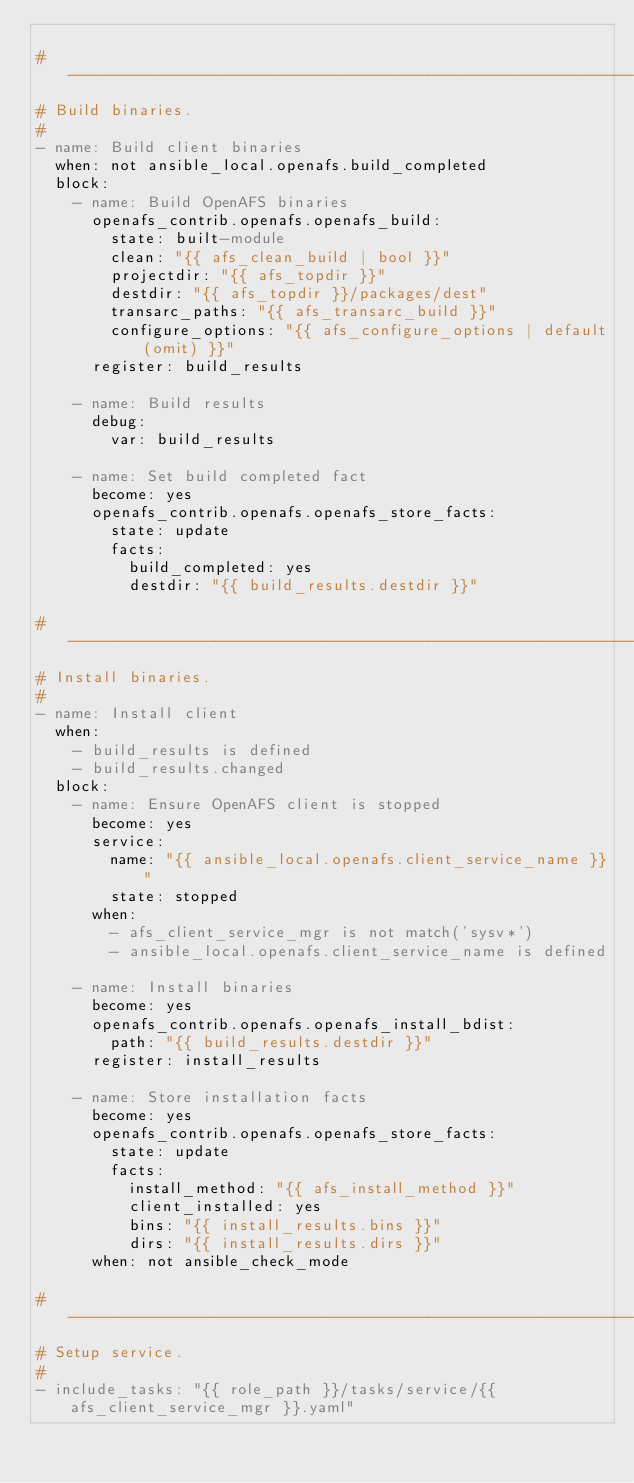Convert code to text. <code><loc_0><loc_0><loc_500><loc_500><_YAML_>
#----------------------------------------------------------------------------
# Build binaries.
#
- name: Build client binaries
  when: not ansible_local.openafs.build_completed
  block:
    - name: Build OpenAFS binaries
      openafs_contrib.openafs.openafs_build:
        state: built-module
        clean: "{{ afs_clean_build | bool }}"
        projectdir: "{{ afs_topdir }}"
        destdir: "{{ afs_topdir }}/packages/dest"
        transarc_paths: "{{ afs_transarc_build }}"
        configure_options: "{{ afs_configure_options | default(omit) }}"
      register: build_results

    - name: Build results
      debug:
        var: build_results

    - name: Set build completed fact
      become: yes
      openafs_contrib.openafs.openafs_store_facts:
        state: update
        facts:
          build_completed: yes
          destdir: "{{ build_results.destdir }}"

#----------------------------------------------------------------------------
# Install binaries.
#
- name: Install client
  when:
    - build_results is defined
    - build_results.changed
  block:
    - name: Ensure OpenAFS client is stopped
      become: yes
      service:
        name: "{{ ansible_local.openafs.client_service_name }}"
        state: stopped
      when:
        - afs_client_service_mgr is not match('sysv*')
        - ansible_local.openafs.client_service_name is defined

    - name: Install binaries
      become: yes
      openafs_contrib.openafs.openafs_install_bdist:
        path: "{{ build_results.destdir }}"
      register: install_results

    - name: Store installation facts
      become: yes
      openafs_contrib.openafs.openafs_store_facts:
        state: update
        facts:
          install_method: "{{ afs_install_method }}"
          client_installed: yes
          bins: "{{ install_results.bins }}"
          dirs: "{{ install_results.dirs }}"
      when: not ansible_check_mode

#----------------------------------------------------------------------------
# Setup service.
#
- include_tasks: "{{ role_path }}/tasks/service/{{ afs_client_service_mgr }}.yaml"
</code> 